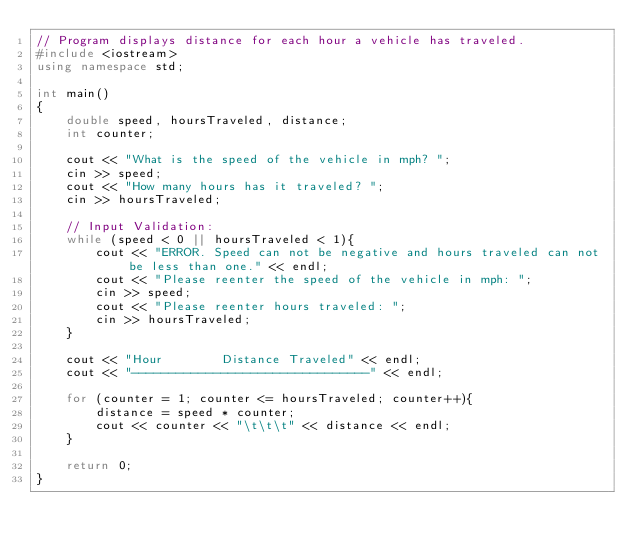Convert code to text. <code><loc_0><loc_0><loc_500><loc_500><_C++_>// Program displays distance for each hour a vehicle has traveled.
#include <iostream>
using namespace std;

int main()
{
    double speed, hoursTraveled, distance;
    int counter;

    cout << "What is the speed of the vehicle in mph? ";
    cin >> speed;
    cout << "How many hours has it traveled? ";
    cin >> hoursTraveled;

    // Input Validation:
    while (speed < 0 || hoursTraveled < 1){
        cout << "ERROR. Speed can not be negative and hours traveled can not be less than one." << endl;
        cout << "Please reenter the speed of the vehicle in mph: ";
        cin >> speed;
        cout << "Please reenter hours traveled: ";
        cin >> hoursTraveled;
    }

    cout << "Hour        Distance Traveled" << endl;
    cout << "--------------------------------" << endl;

    for (counter = 1; counter <= hoursTraveled; counter++){
        distance = speed * counter;
        cout << counter << "\t\t\t" << distance << endl;
    }

    return 0;
}</code> 